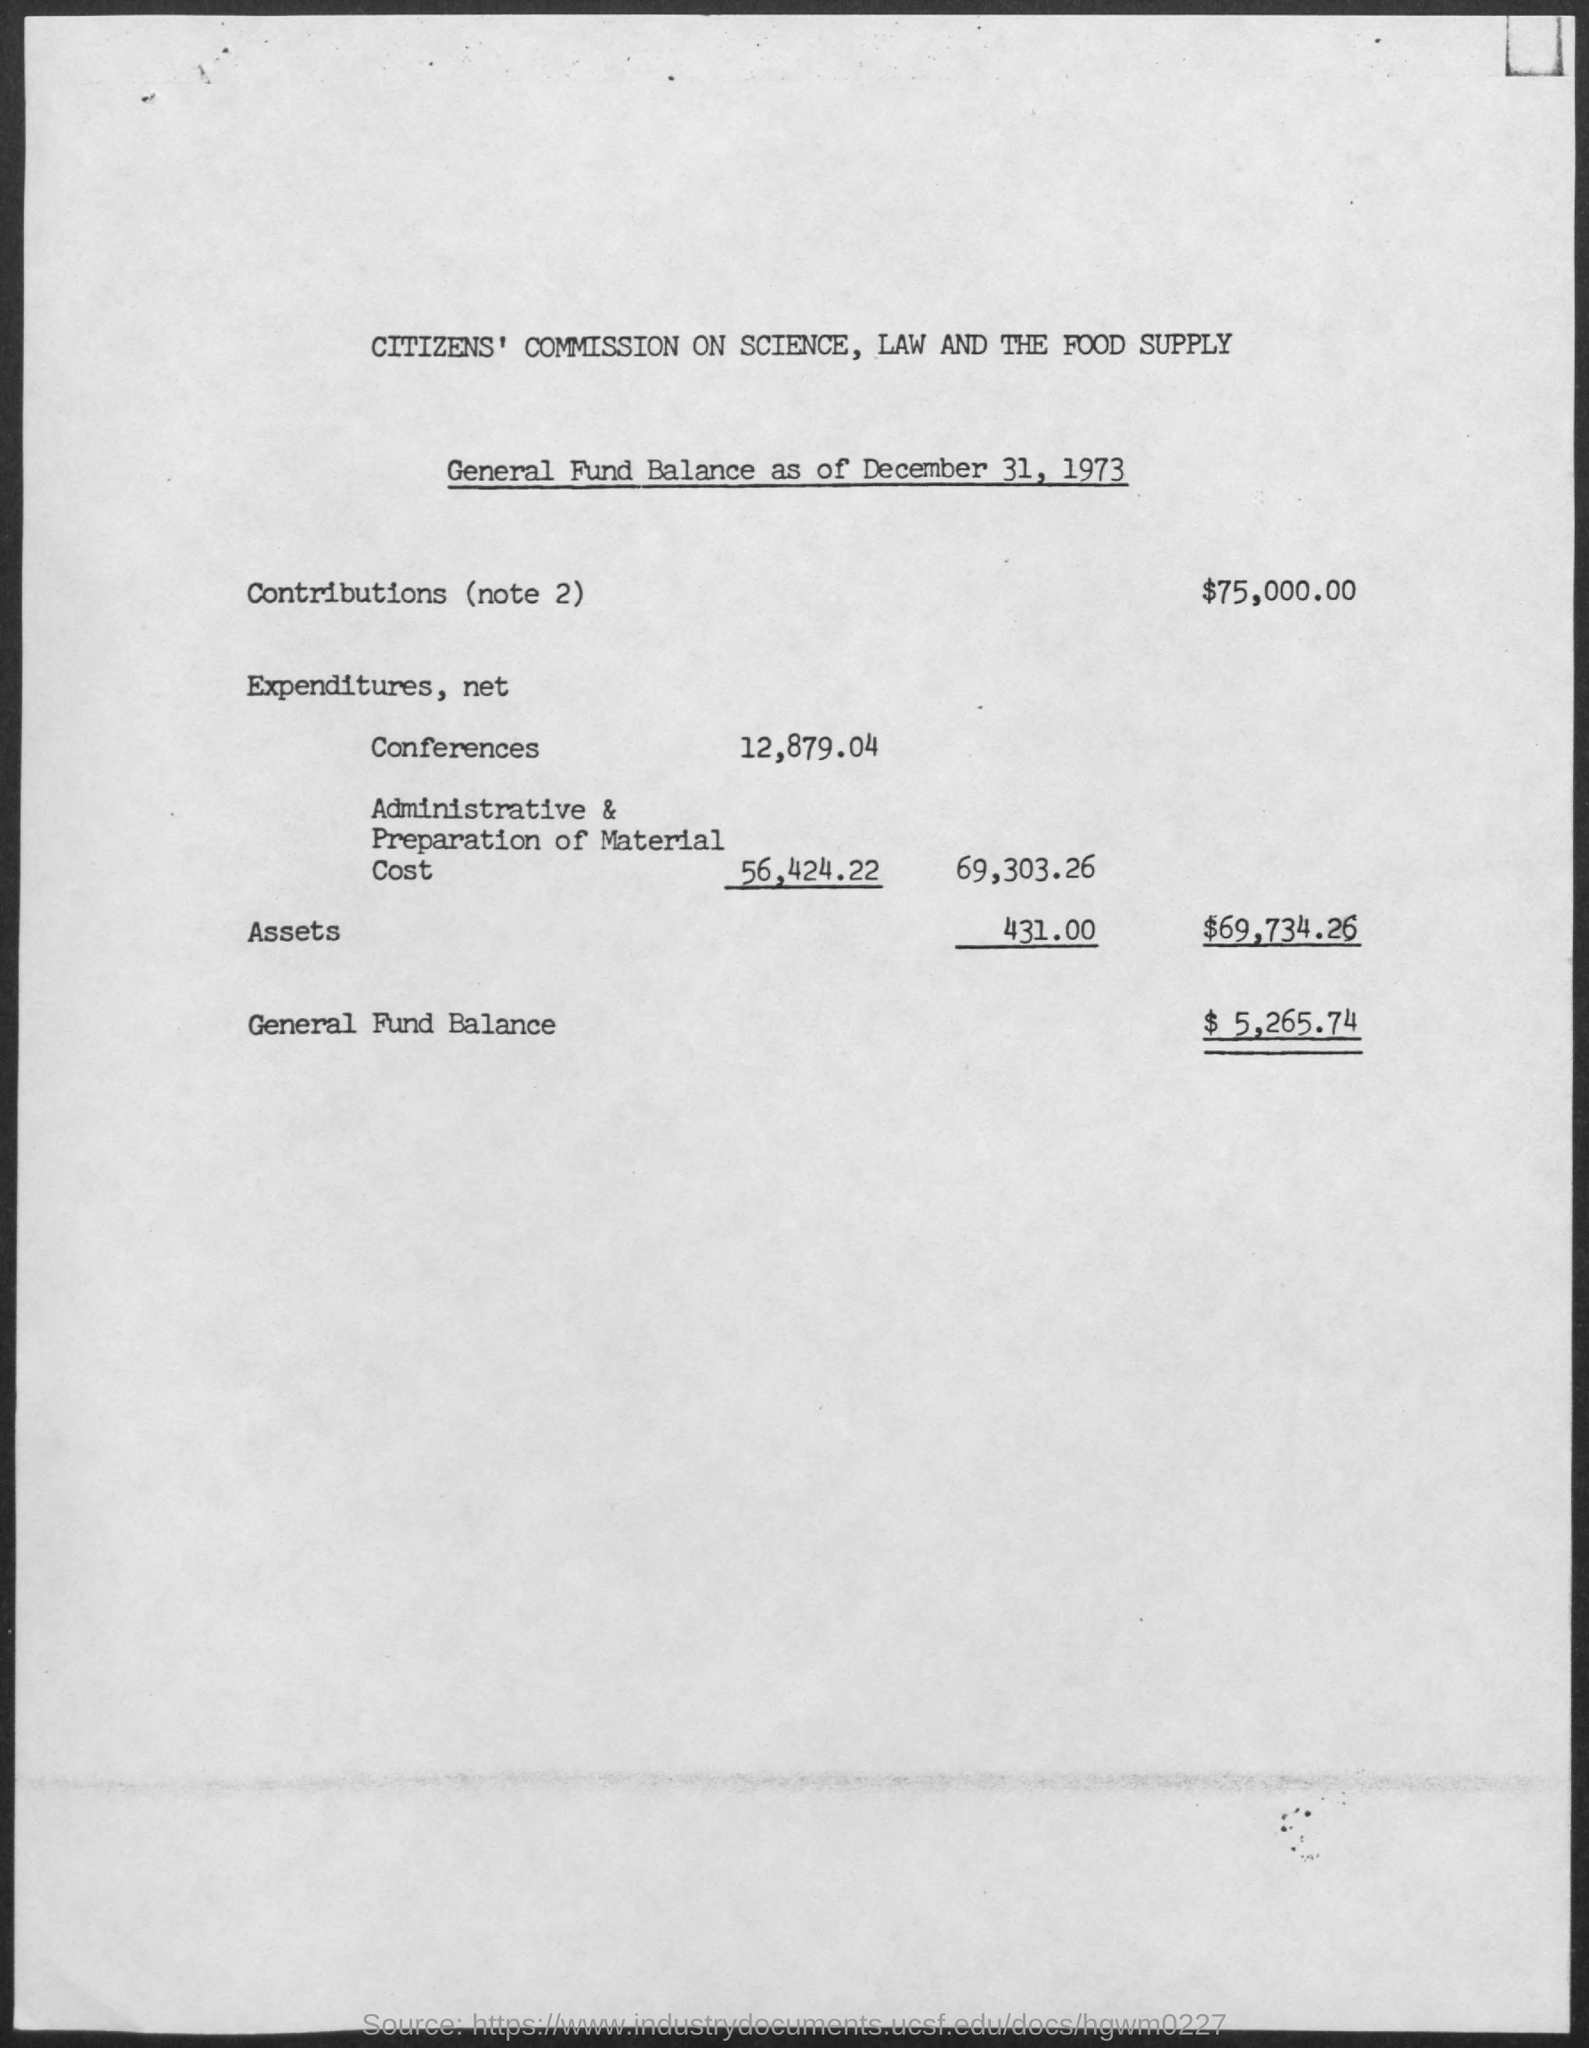Identify some key points in this picture. The general fund balance is $5,265.74. The amount of contributions is $75,000.00. The document concerns the General Fund Balance as of December 31, 1973. The Citizens' Commission On Science, Law and the Food Supply is the institution mentioned at the top of the page. 